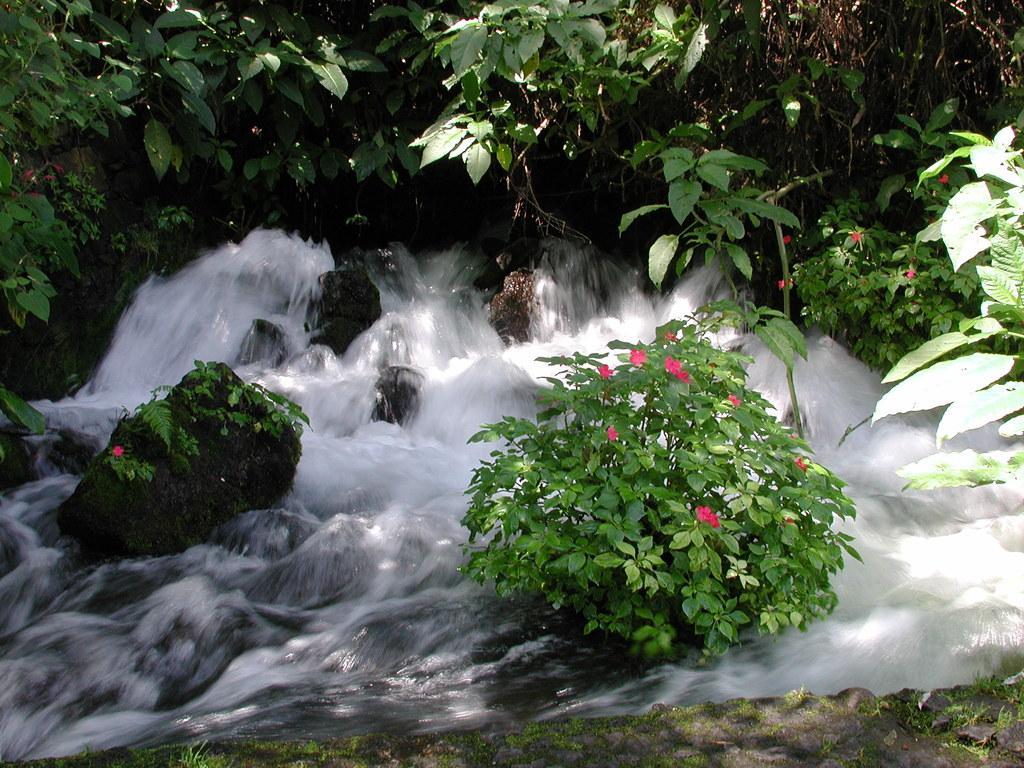Please provide a concise description of this image. In this image, we can see waterfalls, trees and there are plants with flowers. 